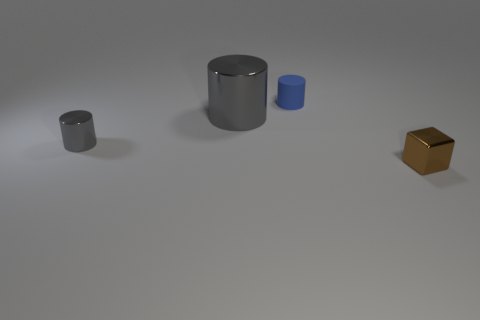Are there any other things that are made of the same material as the blue thing?
Your answer should be very brief. No. Is there anything else that is the same shape as the brown object?
Ensure brevity in your answer.  No. How many things are metallic things to the right of the small blue thing or small things that are in front of the tiny rubber thing?
Make the answer very short. 2. There is a small gray object in front of the blue matte thing; are there any tiny metal cubes behind it?
Provide a succinct answer. No. What is the shape of the brown metallic object that is the same size as the blue object?
Your response must be concise. Cube. How many things are large metal cylinders behind the tiny gray metal cylinder or blue objects?
Offer a terse response. 2. What number of other things are there of the same material as the large cylinder
Your answer should be compact. 2. The other object that is the same color as the large object is what shape?
Offer a very short reply. Cylinder. There is a thing that is behind the big gray thing; how big is it?
Make the answer very short. Small. There is a small brown object that is made of the same material as the big gray cylinder; what is its shape?
Offer a very short reply. Cube. 